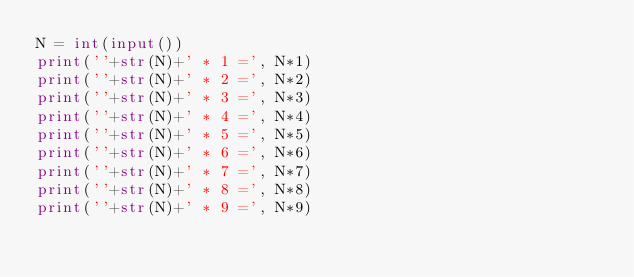Convert code to text. <code><loc_0><loc_0><loc_500><loc_500><_Python_>N = int(input())
print(''+str(N)+' * 1 =', N*1)
print(''+str(N)+' * 2 =', N*2)
print(''+str(N)+' * 3 =', N*3)
print(''+str(N)+' * 4 =', N*4)
print(''+str(N)+' * 5 =', N*5)
print(''+str(N)+' * 6 =', N*6)
print(''+str(N)+' * 7 =', N*7)
print(''+str(N)+' * 8 =', N*8)
print(''+str(N)+' * 9 =', N*9)
</code> 